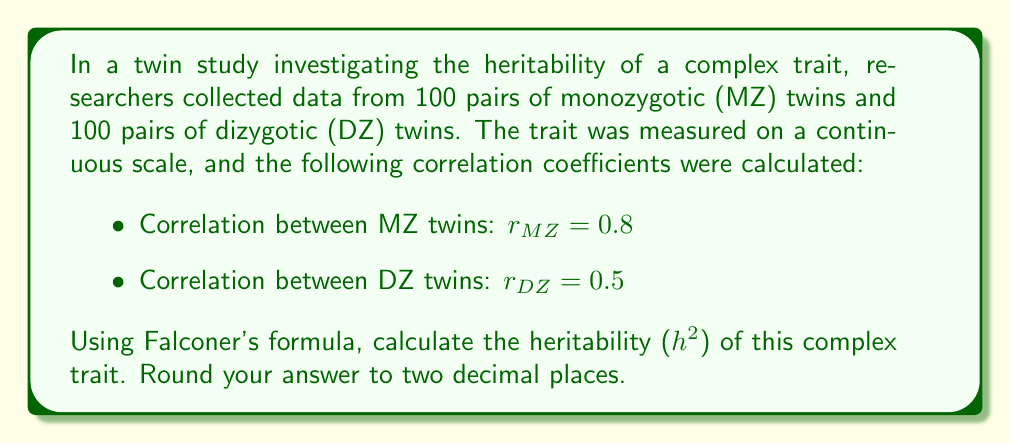Teach me how to tackle this problem. To calculate the heritability of a complex trait using twin study data, we can apply Falconer's formula. This method assumes that the total variance in a trait can be partitioned into genetic and environmental components.

Step 1: Recall Falconer's formula for heritability:
$$h^2 = 2(r_{MZ} - r_{DZ})$$

Where:
$h^2$ is the heritability estimate
$r_{MZ}$ is the correlation coefficient for monozygotic twins
$r_{DZ}$ is the correlation coefficient for dizygotic twins

Step 2: Substitute the given values into the formula:
$$h^2 = 2(0.8 - 0.5)$$

Step 3: Calculate the difference inside the parentheses:
$$h^2 = 2(0.3)$$

Step 4: Multiply by 2:
$$h^2 = 0.6$$

Step 5: Round to two decimal places:
$$h^2 = 0.60$$

The heritability estimate of 0.60 suggests that approximately 60% of the variation in this complex trait can be attributed to genetic factors in this population.
Answer: $h^2 = 0.60$ 